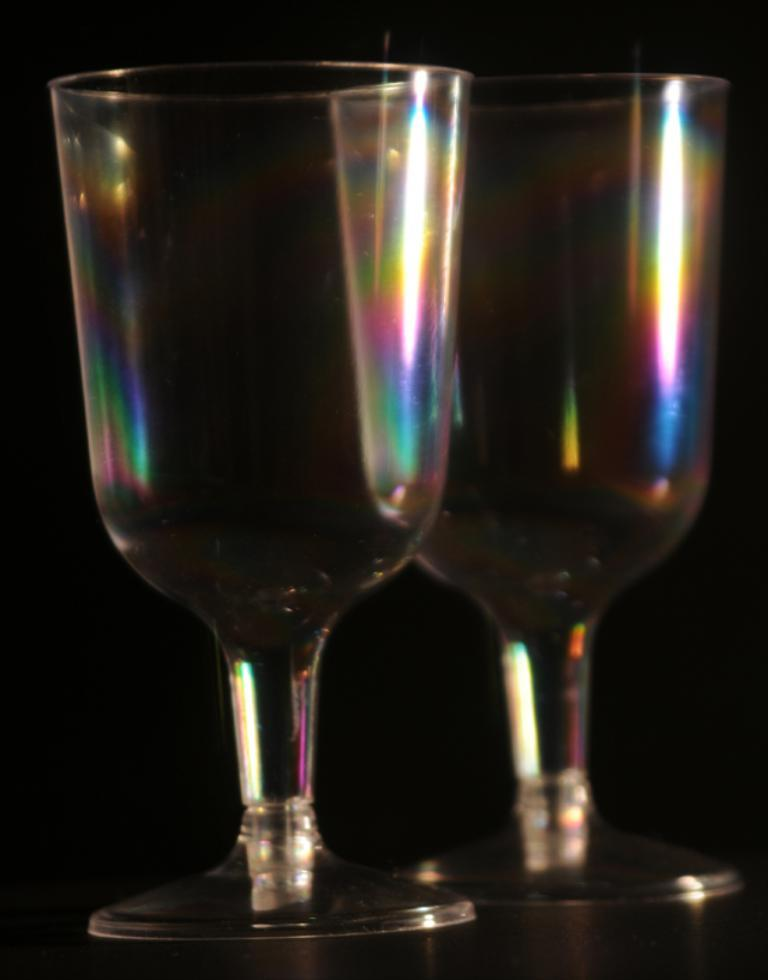How many glasses can be seen in the image? There are two glasses in the image. What can be observed about the background of the image? The background of the image is dark. What type of jam is being spread on the pump in the image? There is no jam or pump present in the image. What time of day is depicted in the image? The provided facts do not mention the time of day, so it cannot be determined from the image. 